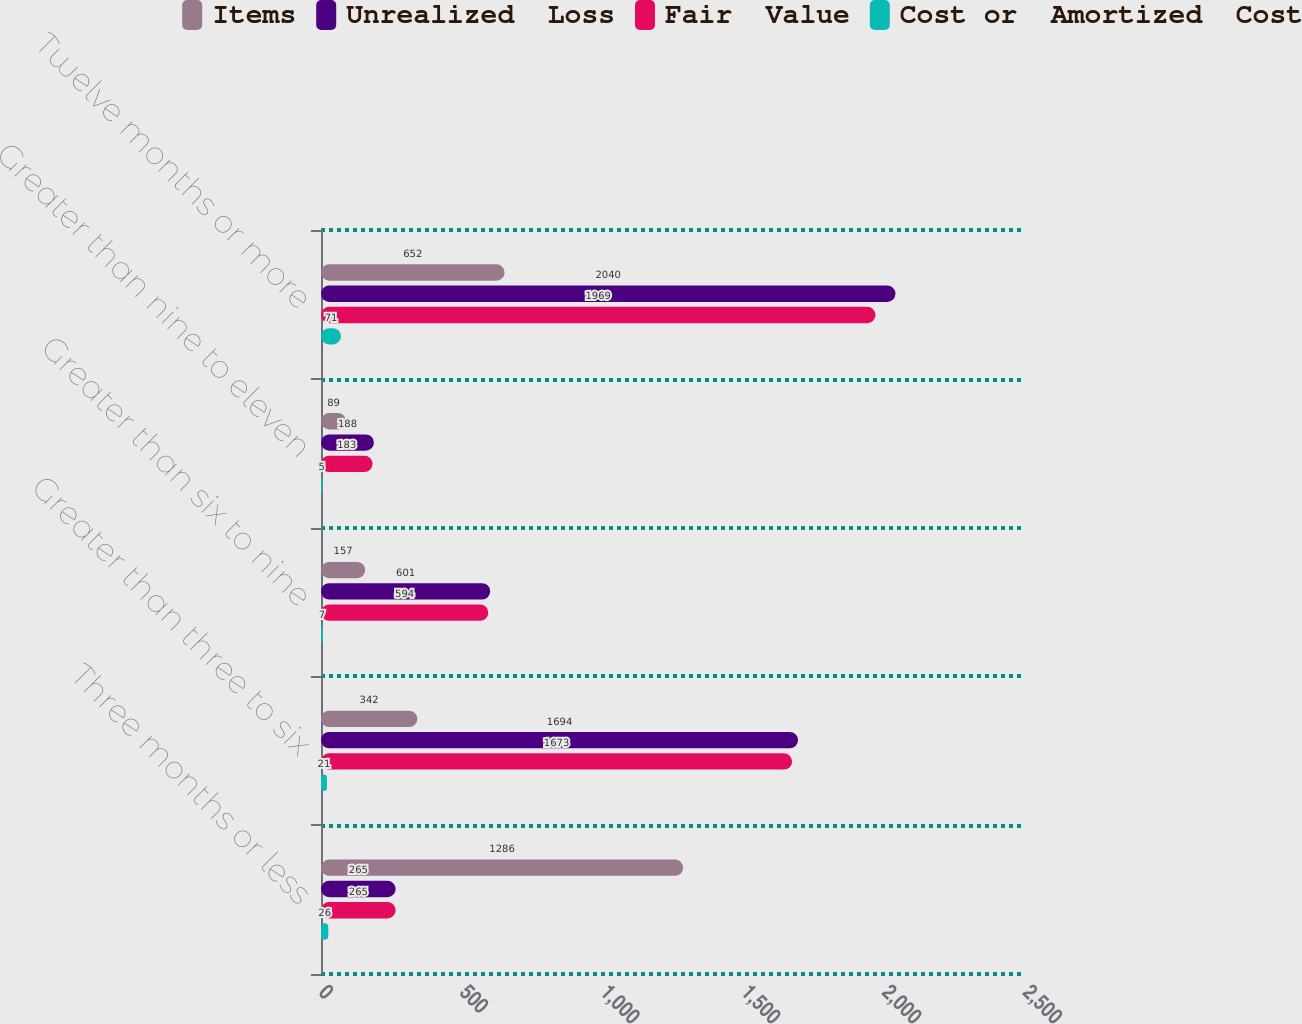<chart> <loc_0><loc_0><loc_500><loc_500><stacked_bar_chart><ecel><fcel>Three months or less<fcel>Greater than three to six<fcel>Greater than six to nine<fcel>Greater than nine to eleven<fcel>Twelve months or more<nl><fcel>Items<fcel>1286<fcel>342<fcel>157<fcel>89<fcel>652<nl><fcel>Unrealized  Loss<fcel>265<fcel>1694<fcel>601<fcel>188<fcel>2040<nl><fcel>Fair  Value<fcel>265<fcel>1673<fcel>594<fcel>183<fcel>1969<nl><fcel>Cost or  Amortized  Cost<fcel>26<fcel>21<fcel>7<fcel>5<fcel>71<nl></chart> 